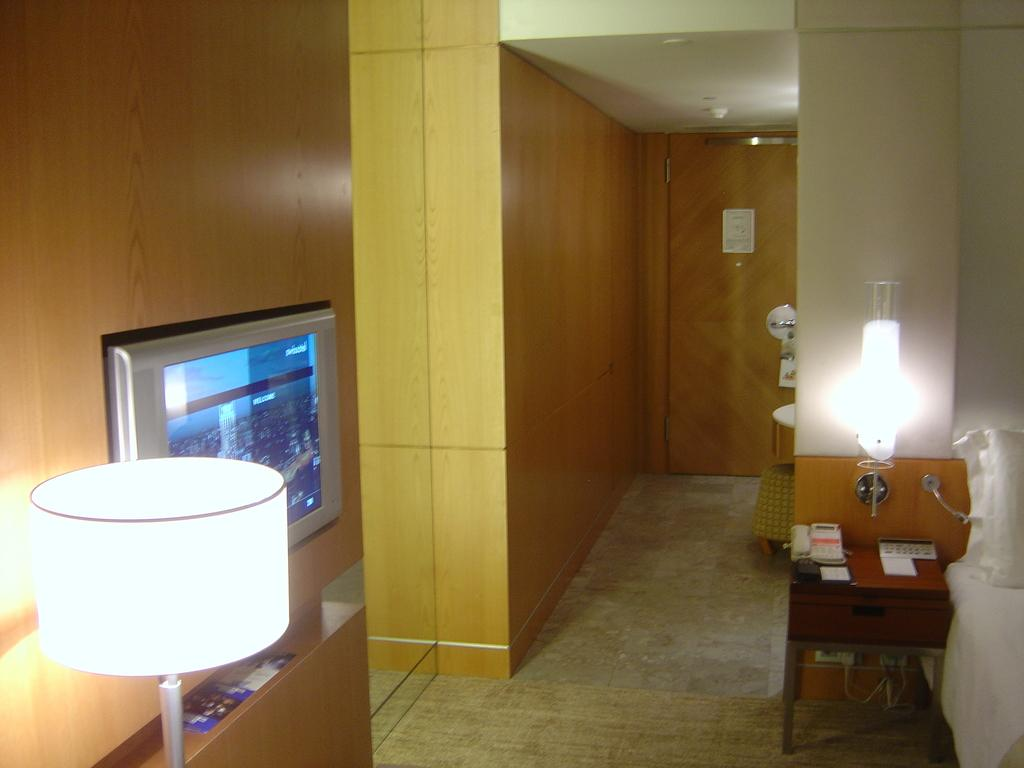What electronic device can be seen in the image? There is a television in the image. How many lights are visible in the image? There are two lights visible in the image. What is on the table in the image? There are objects on a table in the image. What architectural feature can be seen in the background of the image? There is a door in the background of the image. What theory is being discussed by the cat in the image? There is no cat present in the image, so no theory can be discussed. Is there a camera visible in the image? There is no camera mentioned or visible in the image. 